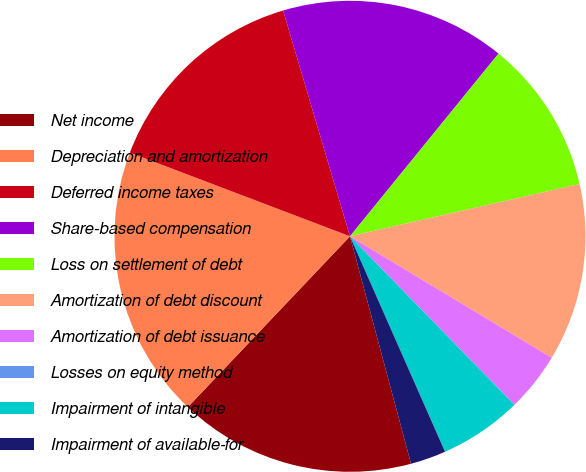Convert chart. <chart><loc_0><loc_0><loc_500><loc_500><pie_chart><fcel>Net income<fcel>Depreciation and amortization<fcel>Deferred income taxes<fcel>Share-based compensation<fcel>Loss on settlement of debt<fcel>Amortization of debt discount<fcel>Amortization of debt issuance<fcel>Losses on equity method<fcel>Impairment of intangible<fcel>Impairment of available-for<nl><fcel>16.26%<fcel>18.7%<fcel>14.63%<fcel>15.45%<fcel>10.57%<fcel>12.19%<fcel>4.07%<fcel>0.0%<fcel>5.69%<fcel>2.44%<nl></chart> 